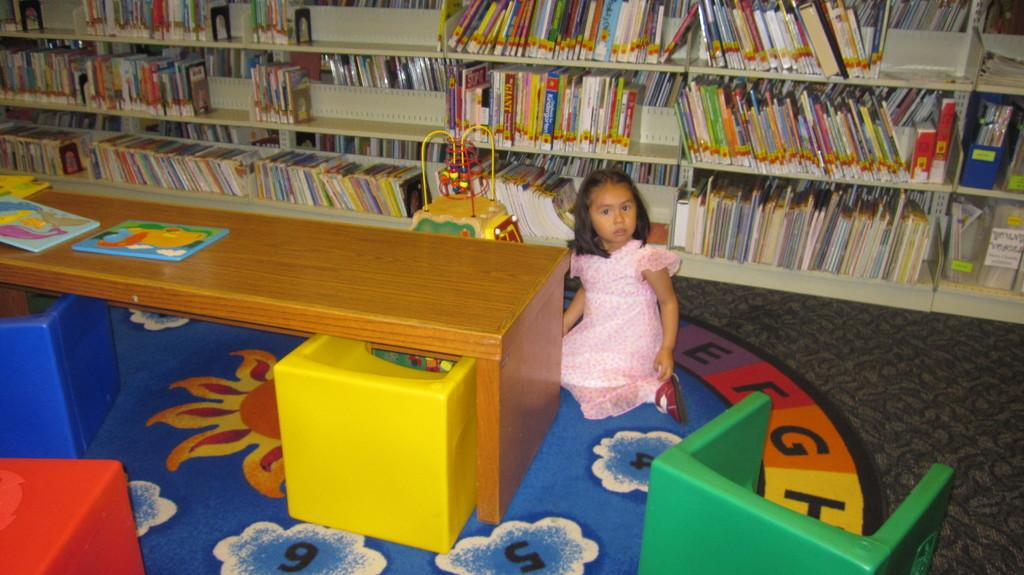What is the main subject of the image? The main subject of the image is a kid. What is the kid wearing in the image? The kid is wearing a pink dress in the image. What is the kid's position in the image? The kid is sitting on the ground in the image. What can be seen on a table in the image? There are some things present on a table in the image. What is visible in the background of the image? There are books arranged in shelves in the background of the image. What type of soup is the kid eating in the image? There is no soup present in the image; the kid is wearing a pink dress and sitting on the ground. Can you see a robin perched on the bookshelf in the image? There is no robin present in the image; only the kid, the pink dress, the sitting position, the table, and the books arranged in shelves can be seen. 